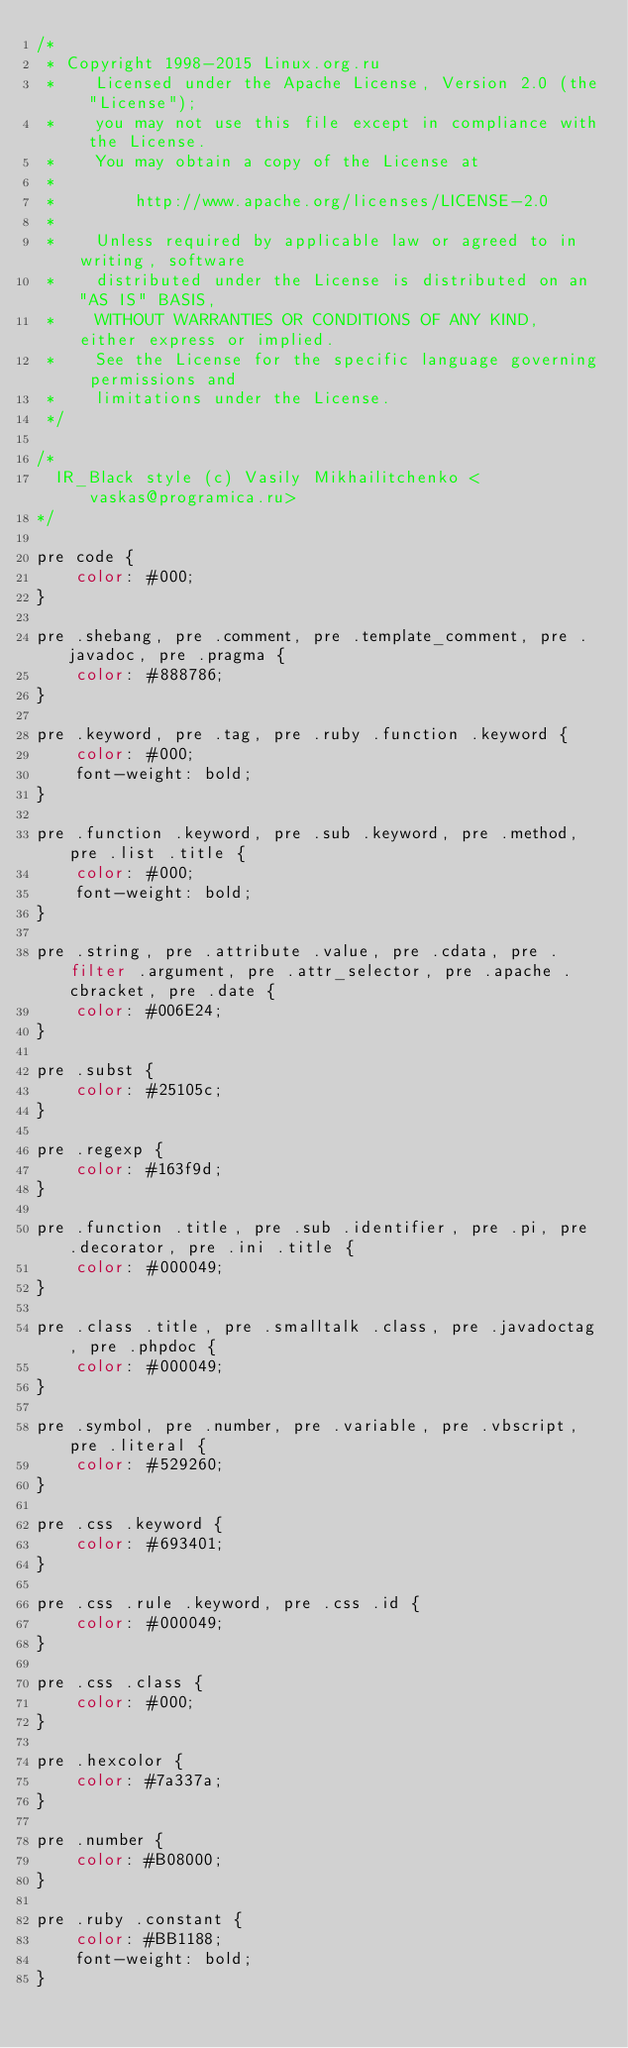<code> <loc_0><loc_0><loc_500><loc_500><_CSS_>/*
 * Copyright 1998-2015 Linux.org.ru
 *    Licensed under the Apache License, Version 2.0 (the "License");
 *    you may not use this file except in compliance with the License.
 *    You may obtain a copy of the License at
 *
 *        http://www.apache.org/licenses/LICENSE-2.0
 *
 *    Unless required by applicable law or agreed to in writing, software
 *    distributed under the License is distributed on an "AS IS" BASIS,
 *    WITHOUT WARRANTIES OR CONDITIONS OF ANY KIND, either express or implied.
 *    See the License for the specific language governing permissions and
 *    limitations under the License.
 */

/*
  IR_Black style (c) Vasily Mikhailitchenko <vaskas@programica.ru>
*/

pre code {
    color: #000;
}

pre .shebang, pre .comment, pre .template_comment, pre .javadoc, pre .pragma {
    color: #888786;
}

pre .keyword, pre .tag, pre .ruby .function .keyword {
    color: #000;
    font-weight: bold;
}

pre .function .keyword, pre .sub .keyword, pre .method, pre .list .title {
    color: #000;
    font-weight: bold;
}

pre .string, pre .attribute .value, pre .cdata, pre .filter .argument, pre .attr_selector, pre .apache .cbracket, pre .date {
    color: #006E24;
}

pre .subst {
    color: #25105c;
}

pre .regexp {
    color: #163f9d;
}

pre .function .title, pre .sub .identifier, pre .pi, pre .decorator, pre .ini .title {
    color: #000049;
}

pre .class .title, pre .smalltalk .class, pre .javadoctag, pre .phpdoc {
    color: #000049;
}

pre .symbol, pre .number, pre .variable, pre .vbscript, pre .literal {
    color: #529260;
}

pre .css .keyword {
    color: #693401;
}

pre .css .rule .keyword, pre .css .id {
    color: #000049;
}

pre .css .class {
    color: #000;
}

pre .hexcolor {
    color: #7a337a;
}

pre .number {
    color: #B08000;
}

pre .ruby .constant {
    color: #BB1188;
    font-weight: bold;
}
</code> 